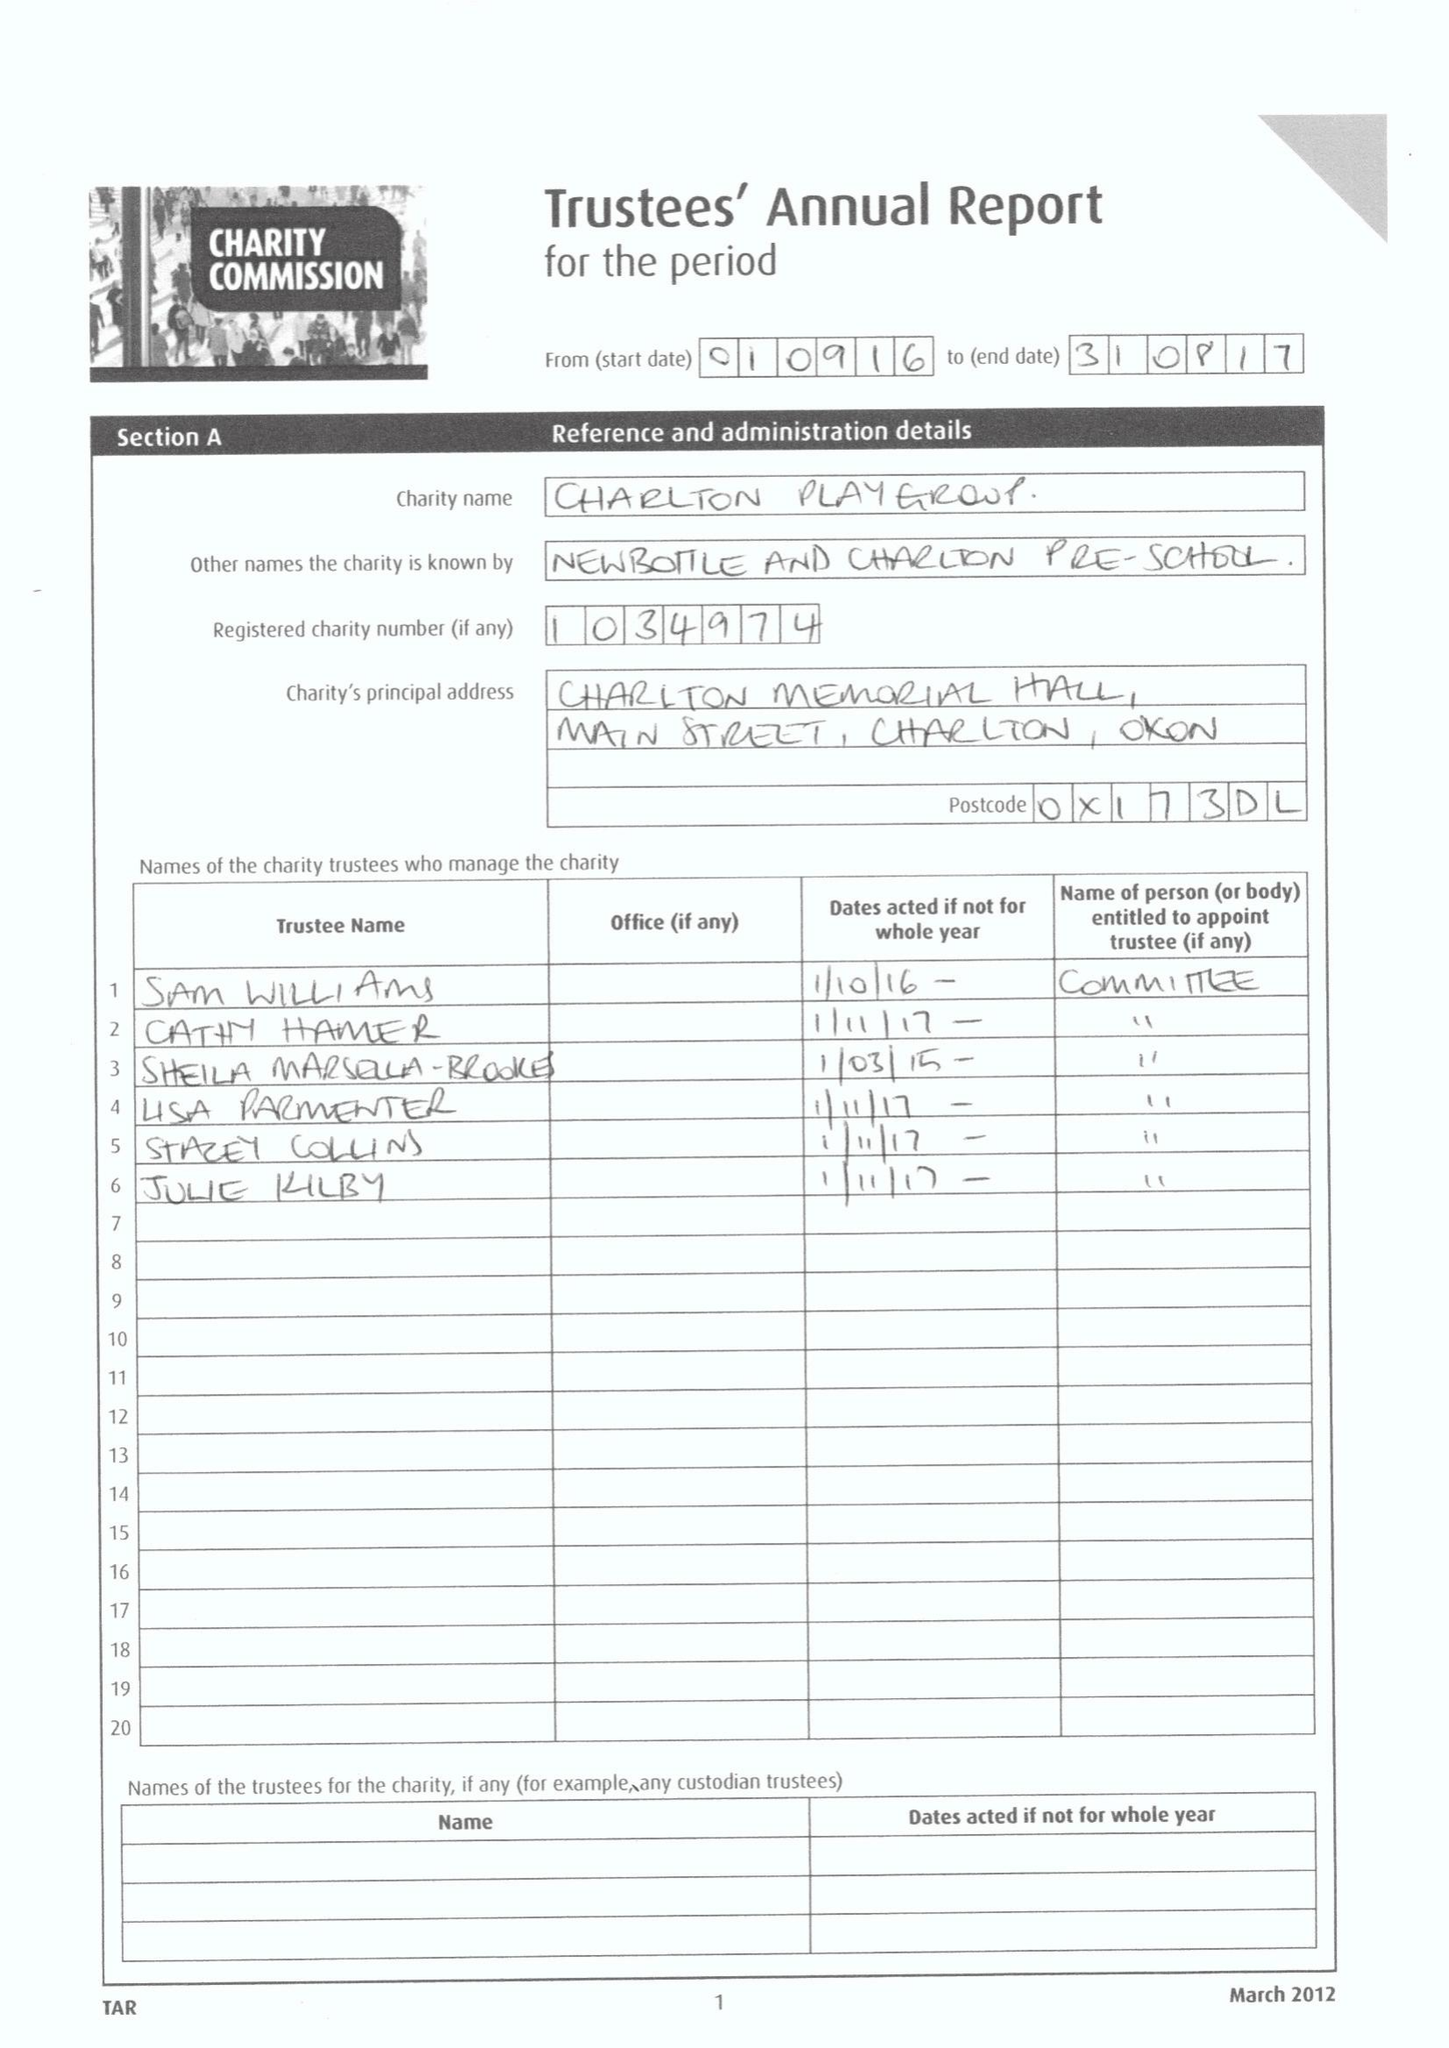What is the value for the address__post_town?
Answer the question using a single word or phrase. None 